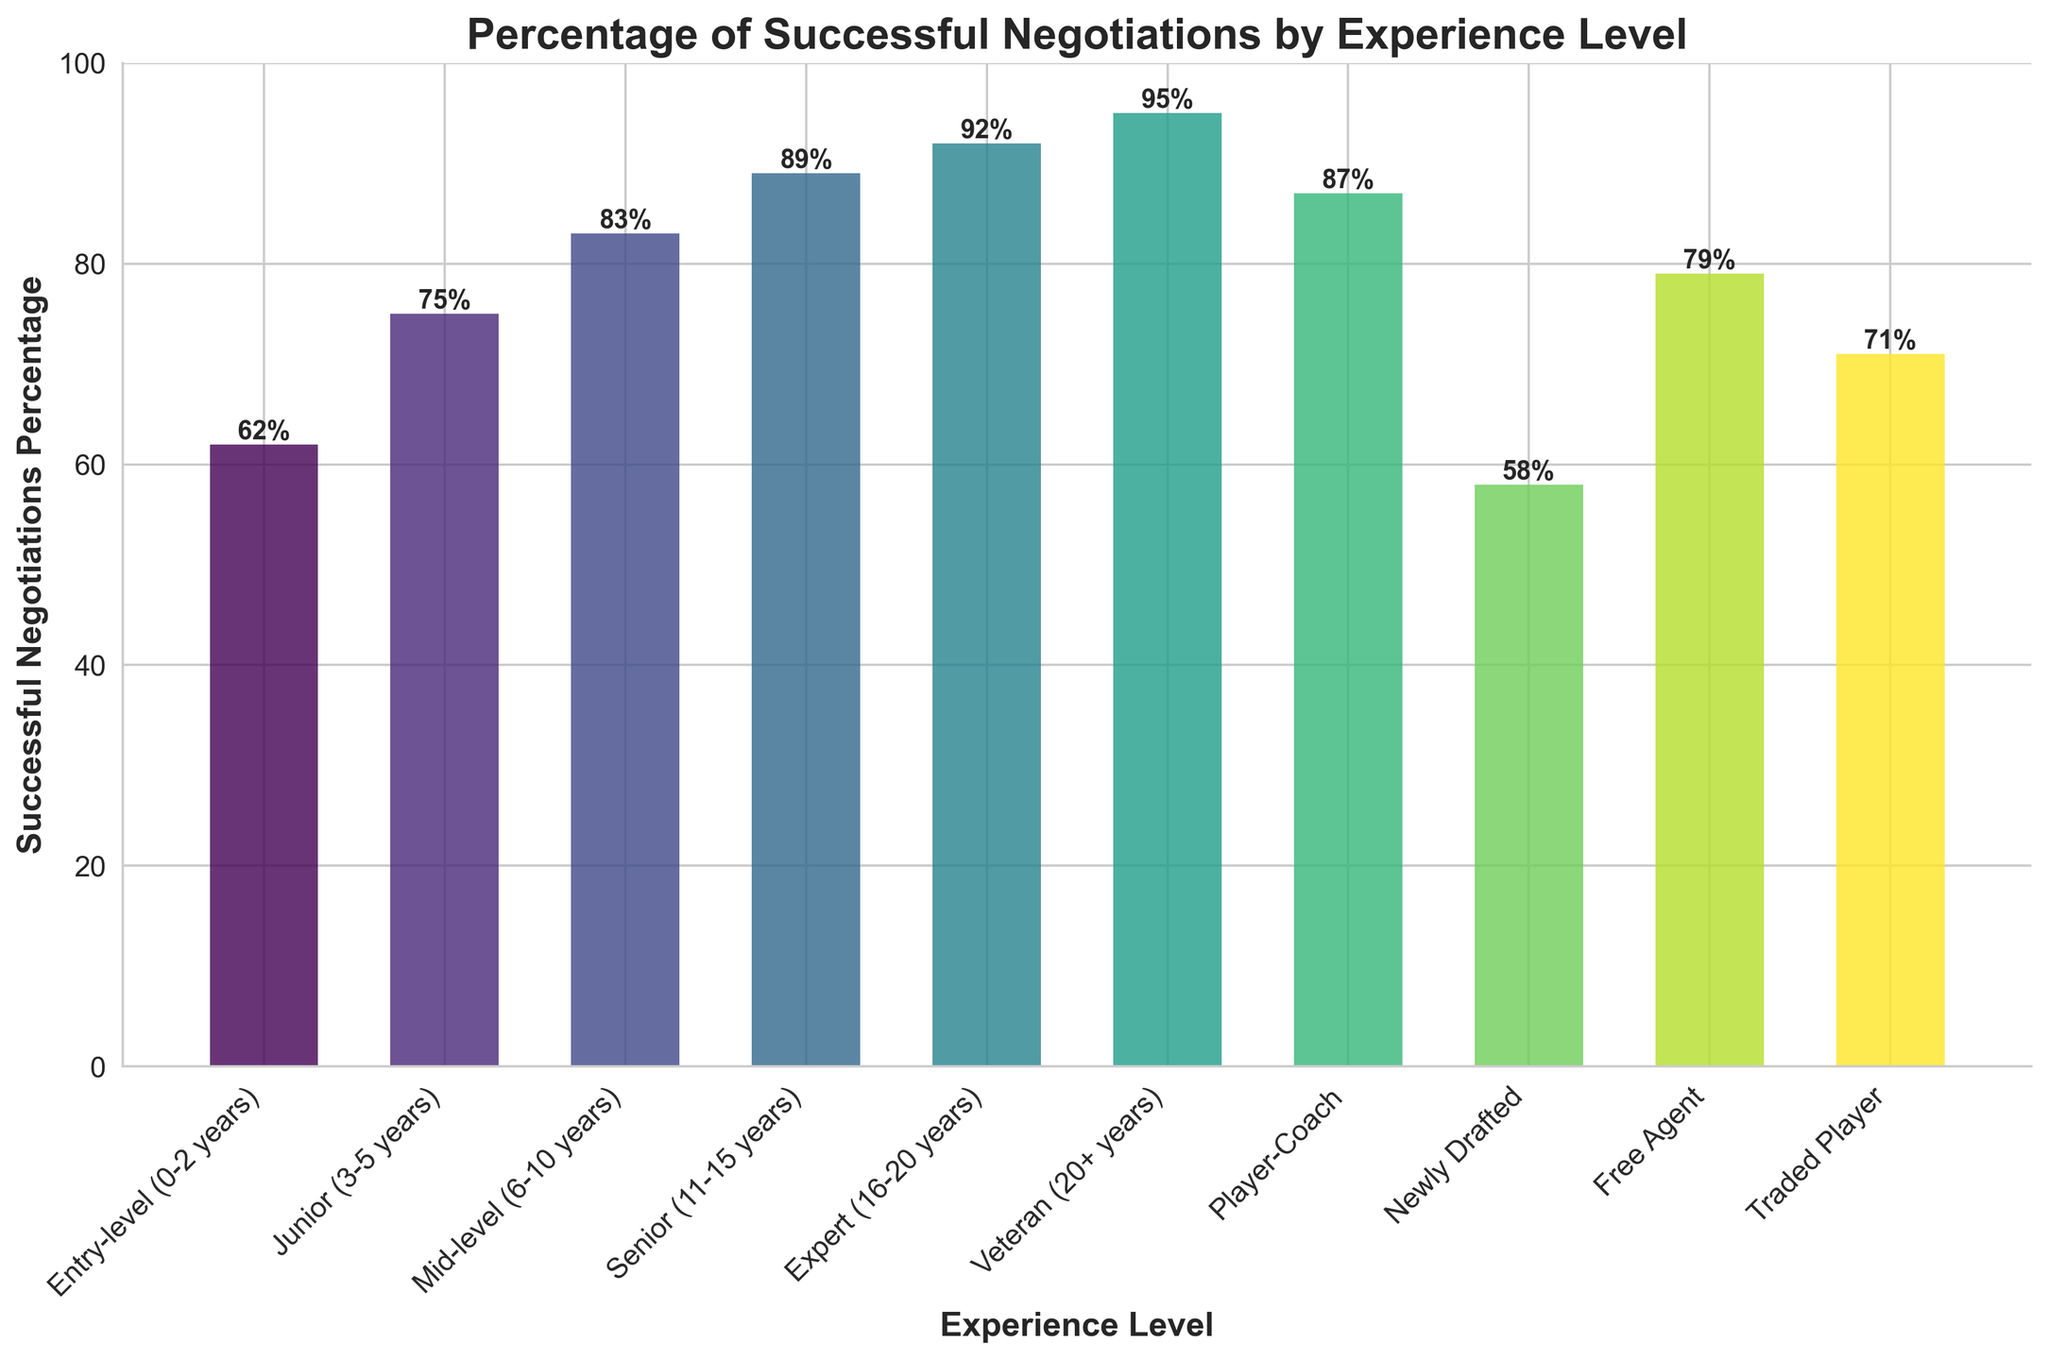Which experience level has the highest percentage of successful negotiations? From the figure, the bar with the highest height represents the Veteran (20+ years) experience level. The value at the top of this bar indicates 95%.
Answer: Veteran (20+ years) What is the difference in successful negotiation percentage between Newly Drafted players and Veterans? The percentage for Newly Drafted players is 58%, and for Veterans, it is 95%. The difference is 95% - 58% = 37%.
Answer: 37% How does the percentage of successful negotiations for Free Agents compare to that of Mid-level players? The bar for Free Agents indicates 79%, and for Mid-level players, it shows 83%. Subtracting these two values gives 83% - 79% = 4%.
Answer: Mid-level is 4% higher What is the average successful negotiation percentage for Entry-level, Junior, and Mid-level players? Adding the percentages: 62% (Entry-level) + 75% (Junior) + 83% (Mid-level) = 220%. Dividing by 3 gives 220% / 3 ≈ 73.33%.
Answer: 73.33% Which two experience levels have the closest percentages of successful negotiations? By inspecting the heights of the bars, we see that Traded Player (71%) and Junior (75%) experience levels have the closest values. The difference is 75% - 71% = 4%.
Answer: Traded Player and Junior How much more successful are Senior negotiations compared to Entry-level negotiations? The percentage for Senior is 89%, and for Entry-level, it is 62%. The difference is 89% - 62% = 27%.
Answer: 27% Can you rank the experience levels from least successful to most successful negotiations? The percentages in ascending order are: Newly Drafted (58%), Entry-level (62%), Traded Player (71%), Junior (75%), Free Agent (79%), Mid-level (83%), Player-Coach (87%), Senior (89%), Expert (92%), Veteran (95%).
Answer: Newly Drafted, Entry-level, Traded Player, Junior, Free Agent, Mid-level, Player-Coach, Senior, Expert, Veteran What's the median percentage of successful negotiations across all experience levels? Listing the percentages in ascending order: 58%, 62%, 71%, 75%, 79%, 83%, 87%, 89%, 92%, and 95%. The median value is the average of the 5th and 6th values because there are 10 data points: (79% + 83%)/2 = 81%.
Answer: 81% What is the total percentage of successful negotiations for Entry-level, Junior, and Senior players combined? Summing the percentages for these experience levels: 62% (Entry-level) + 75% (Junior) + 89% (Senior) = 226%.
Answer: 226% If you were to highlight two bars that represent the highest and the lowest successful negotiations percentages, which colors will they be? The bar representing the highest percentage is for Veteran experience level, and the bar representing the newly drafted level shows the lowest percentage. The respective colors for these bars will be shown in the figure based on their positions in the gradient.
Answer: Colors of Veteran and Newly Drafted 